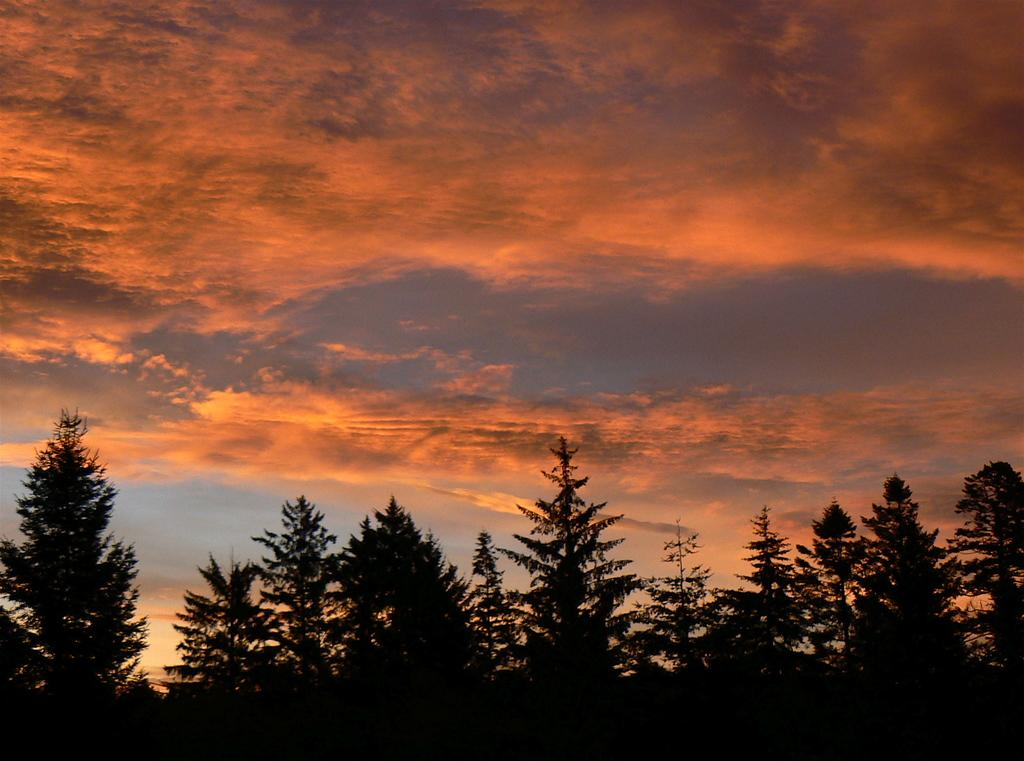What type of vegetation can be seen in the image? There are trees in the image. What can be seen in the sky in the image? There are clouds in the image. What type of oil is being used to maintain the trees in the image? There is no indication of any oil being used to maintain the trees in the image. Is the grandfather wearing a suit in the image? There is no person, let alone a grandfather, present in the image. 